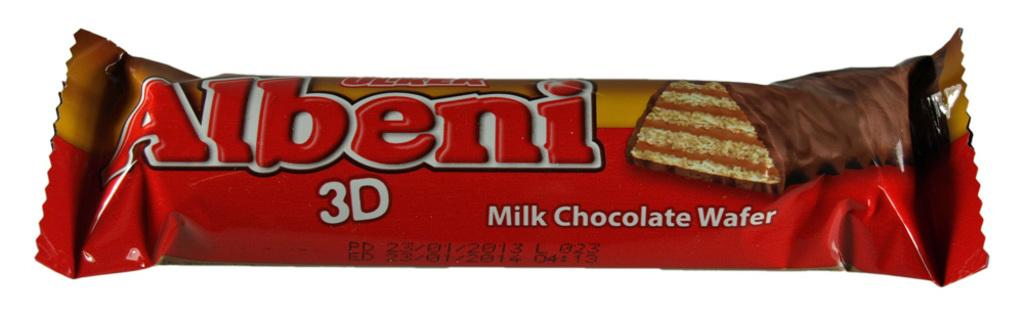What type of food is featured on the chocolate cover in the image? The chocolate cover in the image features chocolate. What can be seen on the chocolate cover besides the chocolate image? Something is written on the chocolate cover. Can you describe the image on the chocolate cover? There is an image of chocolate on the cover. What type of education can be seen being taught on the chocolate cover? There is no education or teaching depicted on the chocolate cover; it features chocolate and an image of chocolate. 